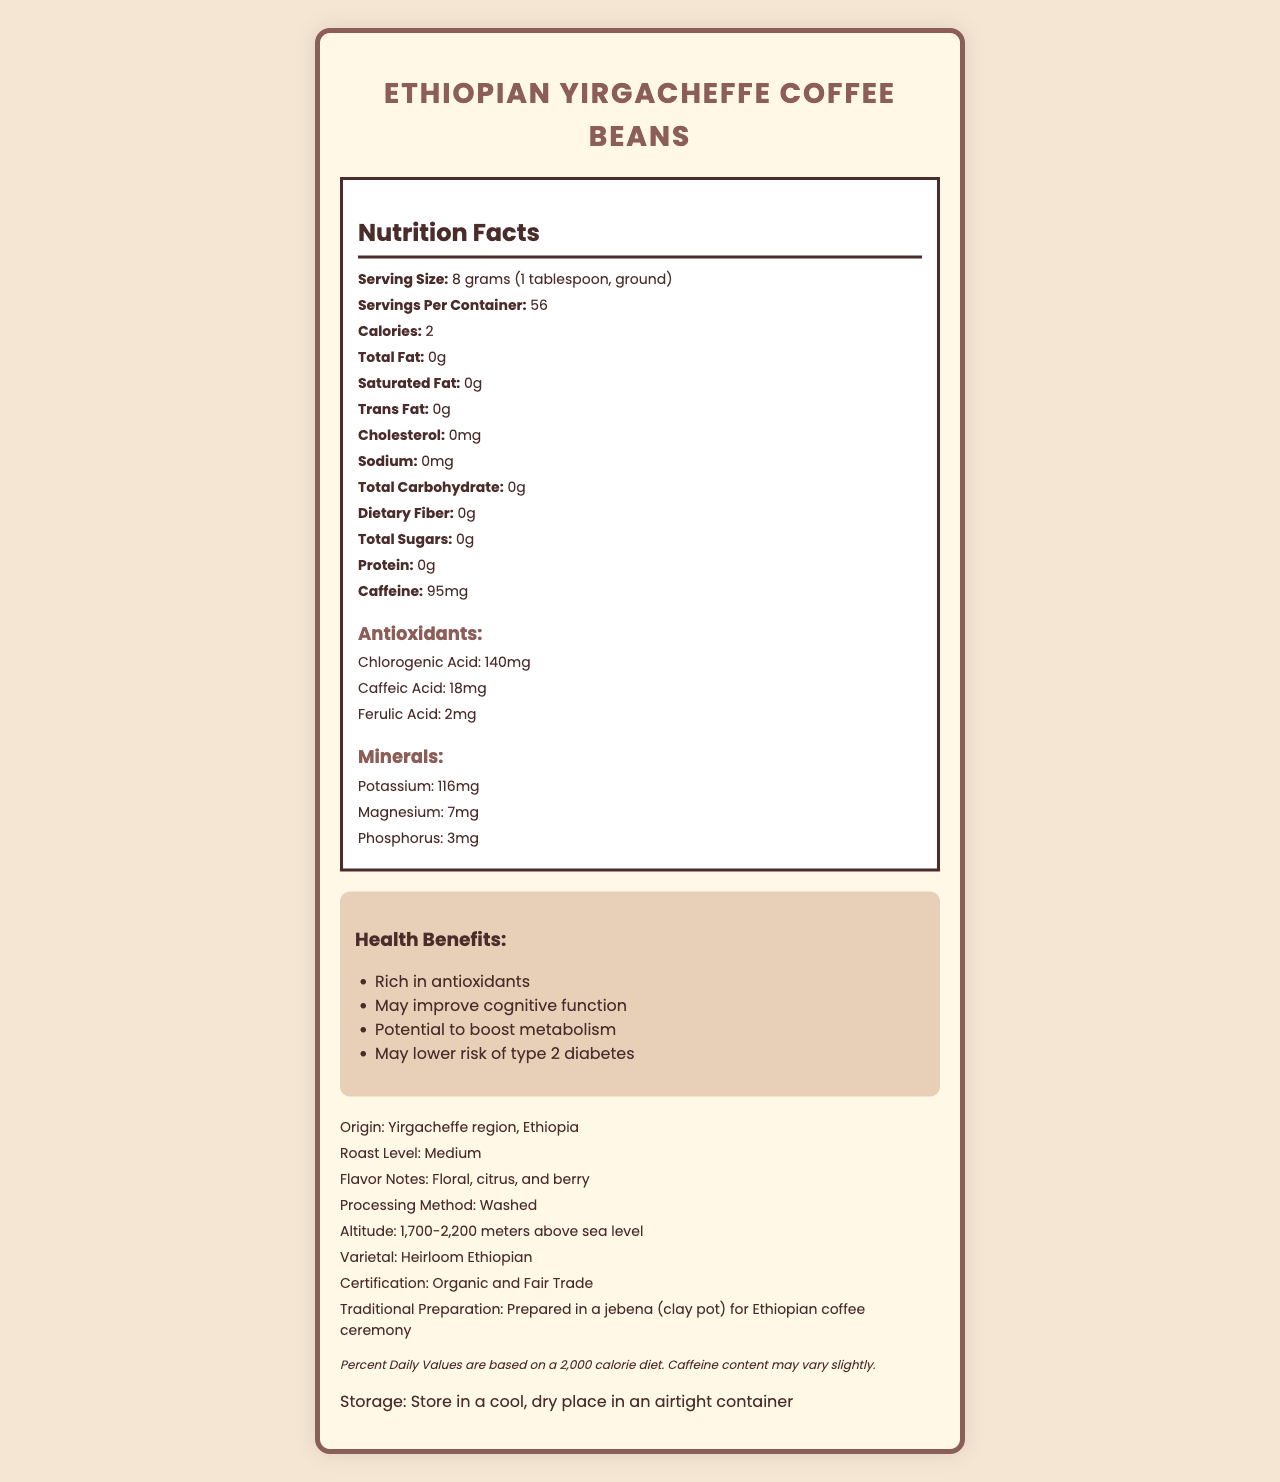what is the serving size for Ethiopian Yirgacheffe Coffee Beans? The serving size is clearly mentioned under the Nutrition Facts, indicating it is 8 grams (1 tablespoon, ground).
Answer: 8 grams (1 tablespoon, ground) how many calories are in each serving? According to the Nutrition Facts, each serving contains 2 calories.
Answer: 2 what is the caffeine content per serving? The Nutrition Facts label specifies that there are 95mg of caffeine per serving.
Answer: 95mg how many servings are there per container? The document states that there are 56 servings per container.
Answer: 56 what are the main antioxidant components mentioned? Under the Antioxidants section, the main components listed are Chlorogenic Acid (140mg), Caffeic Acid (18mg), and Ferulic Acid (2mg).
Answer: Chlorogenic Acid, Caffeic Acid, Ferulic Acid what minerals are present, and in what quantities? The Minerals section lists Potassium (116mg), Magnesium (7mg), and Phosphorus (3mg).
Answer: Potassium: 116mg, Magnesium: 7mg, Phosphorus: 3mg what is the processing method used for these coffee beans? The Origin Info section states that the processing method is "Washed".
Answer: Washed what are the flavor notes of the Ethiopian Yirgacheffe Coffee Beans? The document lists the flavor notes as Floral, citrus, and berry under the Origin Info section.
Answer: Floral, citrus, and berry what altitude are these coffee beans grown at? The Origin Info section states the altitude range as 1,700-2,200 meters above sea level.
Answer: 1,700-2,200 meters above sea level is there any cholesterol in a serving of Ethiopian Yirgacheffe Coffee Beans? The Nutrition Facts show that the cholesterol content is 0mg, indicating that there is no cholesterol.
Answer: No describe the entire document briefly. The document provides detailed information on various aspects of Ethiopian Yirgacheffe Coffee Beans, ranging from nutritional information to health benefits, origin details, and more.
Answer: The document is a comprehensive Nutrition Facts label for Ethiopian Yirgacheffe Coffee Beans. It details serving sizes, nutritional content, caffeine and antioxidant levels, mineral content, origin and processing methods, flavor notes, health benefits, and storage instructions. The document also includes information about the traditional preparation method in a jebena for Ethiopian coffee ceremonies and emphasizes its organic and fair trade certification. what is the traditional preparation method mentioned? The document specifies that the traditional preparation is done in a jebena (clay pot) for Ethiopian coffee ceremonies.
Answer: Prepared in a jebena (clay pot) for Ethiopian coffee ceremony how much dietary fiber is in a serving? The Nutrition Facts show that there is 0g of dietary fiber in each serving.
Answer: 0g how does the caffeine content of these coffee beans compare to typical brewed coffee? The document provides the caffeine content of the coffee beans but does not offer a comparison to typical brewed coffee.
Answer: Cannot be determined what certification does the Ethiopian Yirgacheffe Coffee Beans hold? The Origin Info section mentions that the coffee beans are certified Organic and Fair Trade.
Answer: Organic and Fair Trade 